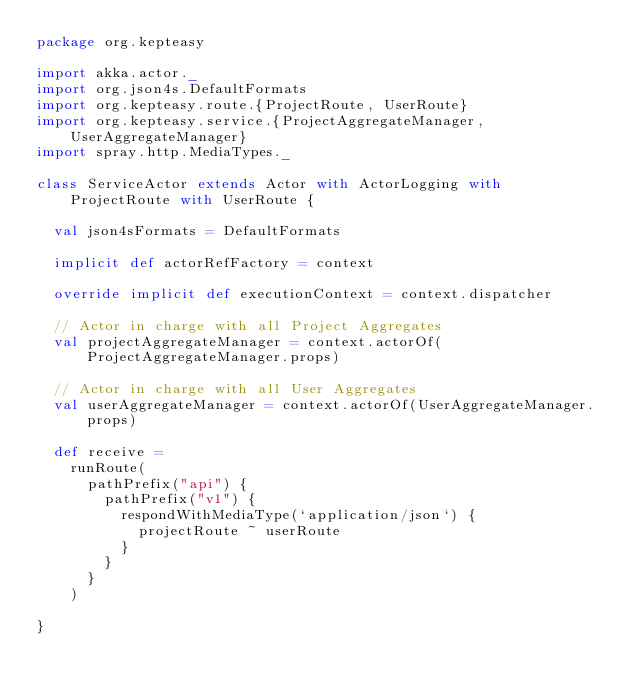<code> <loc_0><loc_0><loc_500><loc_500><_Scala_>package org.kepteasy

import akka.actor._
import org.json4s.DefaultFormats
import org.kepteasy.route.{ProjectRoute, UserRoute}
import org.kepteasy.service.{ProjectAggregateManager, UserAggregateManager}
import spray.http.MediaTypes._

class ServiceActor extends Actor with ActorLogging with ProjectRoute with UserRoute {

  val json4sFormats = DefaultFormats

  implicit def actorRefFactory = context

  override implicit def executionContext = context.dispatcher

  // Actor in charge with all Project Aggregates
  val projectAggregateManager = context.actorOf(ProjectAggregateManager.props)

  // Actor in charge with all User Aggregates
  val userAggregateManager = context.actorOf(UserAggregateManager.props)

  def receive =
    runRoute(
      pathPrefix("api") {
        pathPrefix("v1") {
          respondWithMediaType(`application/json`) {
            projectRoute ~ userRoute
          }
        }
      }
    )

}</code> 